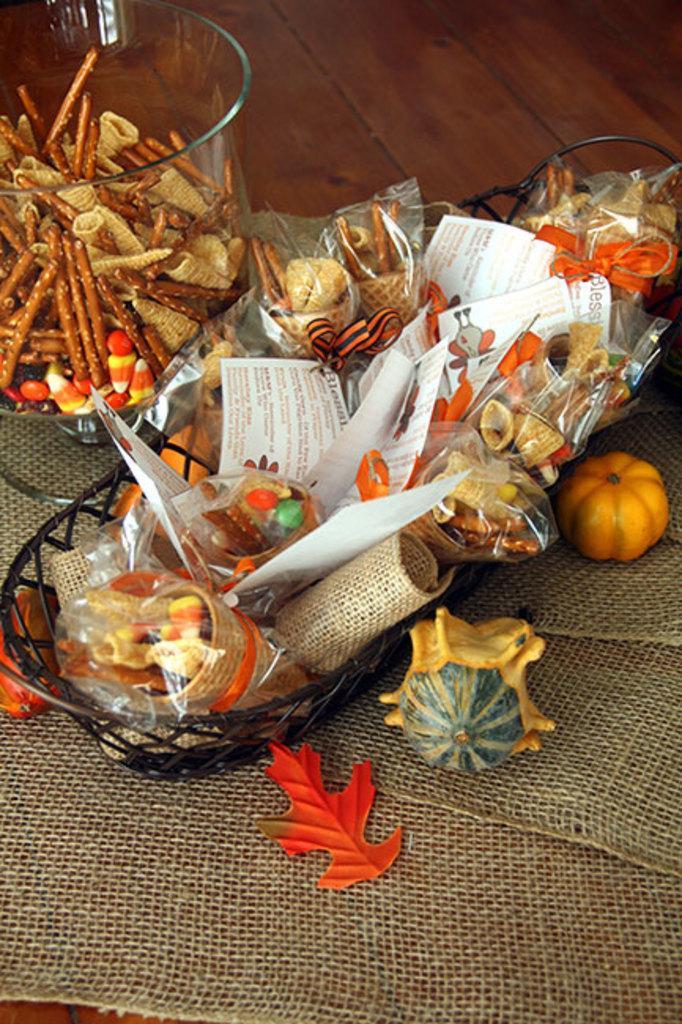How would you summarize this image in a sentence or two? In this picture I can see the brown color surface on which there is a brown color cloth on which I can see a glass jar, in which there are number of candies and side to the jar I can see the basket on which there are covers in which there are few more candies and I can see few papers and I can see a small pumpkin, depiction of a leaf and a thing near the basket. 